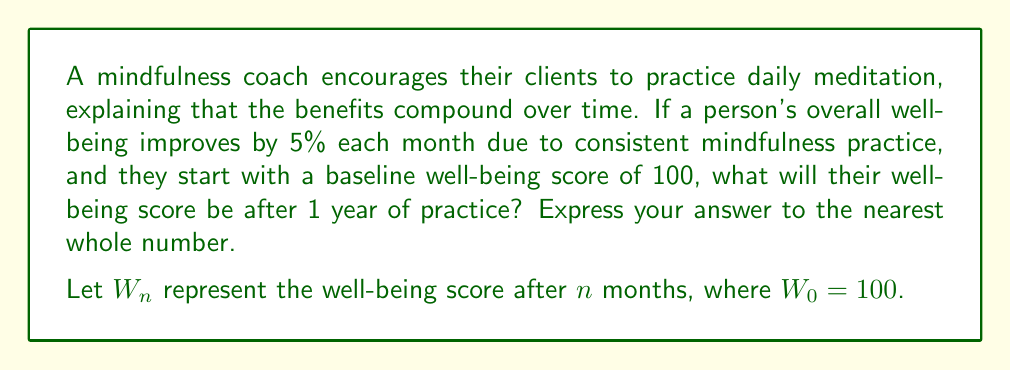Teach me how to tackle this problem. To solve this problem, we need to use the compound interest formula, as the well-being improvement compounds monthly:

$$ W_n = W_0 \cdot (1 + r)^n $$

Where:
$W_n$ = Well-being score after $n$ months
$W_0$ = Initial well-being score (100)
$r$ = Monthly rate of improvement (5% = 0.05)
$n$ = Number of months (12 for one year)

Let's plug in the values:

$$ W_{12} = 100 \cdot (1 + 0.05)^{12} $$

Now we can calculate:

$$ W_{12} = 100 \cdot (1.05)^{12} $$
$$ W_{12} = 100 \cdot 1.7958647773 $$
$$ W_{12} = 179.58647773 $$

Rounding to the nearest whole number:

$$ W_{12} \approx 180 $$

This result shows that consistent daily mindfulness practice can lead to a significant improvement in overall well-being over the course of a year, aligning with Thich Nhat Hanh's teachings on the transformative power of mindfulness.
Answer: 180 